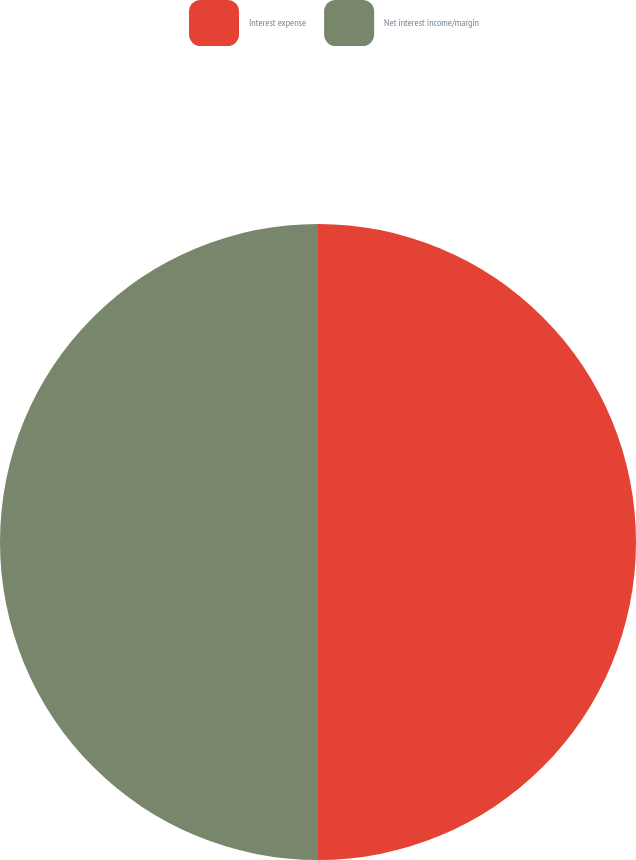Convert chart to OTSL. <chart><loc_0><loc_0><loc_500><loc_500><pie_chart><fcel>Interest expense<fcel>Net interest income/margin<nl><fcel>50.0%<fcel>50.0%<nl></chart> 